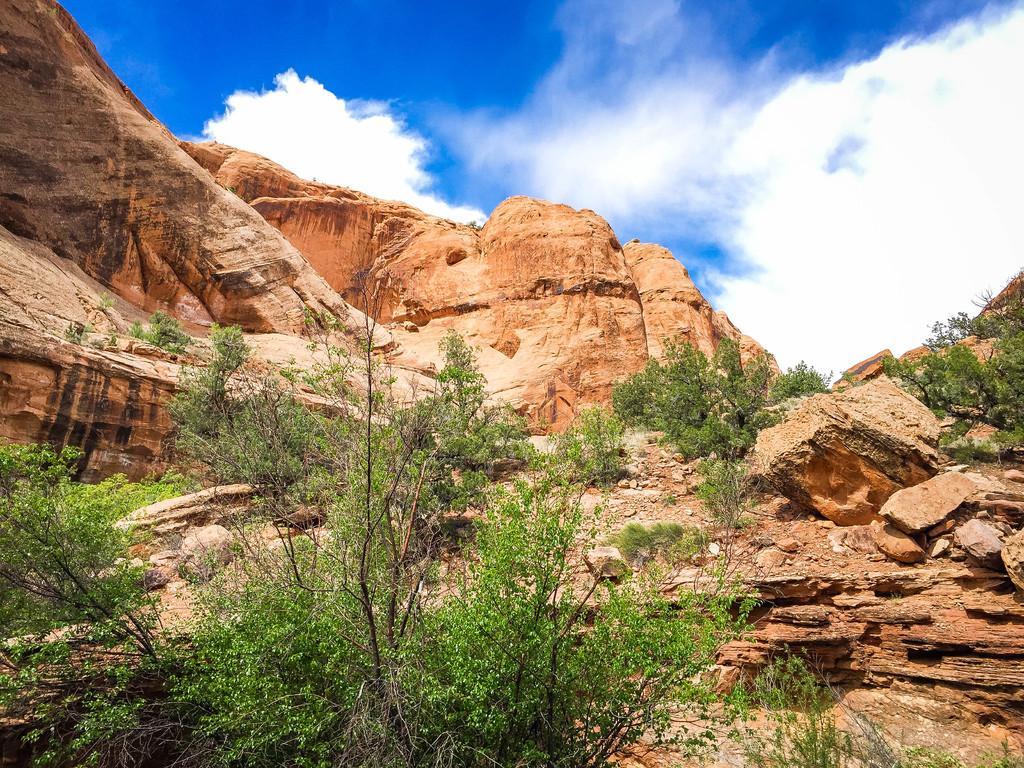In one or two sentences, can you explain what this image depicts? In this image, we can see some hills. We can also see some rocks, trees and plants. We can see the sky with clouds. 